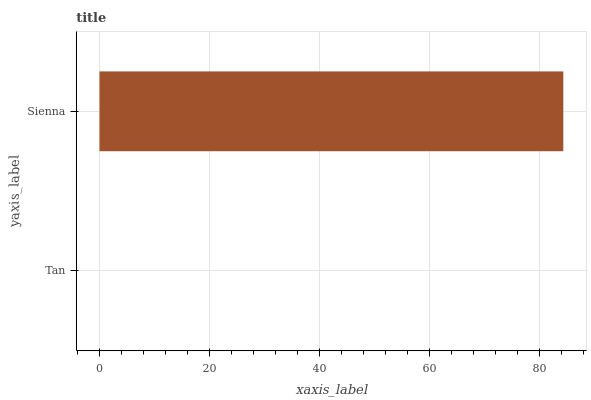Is Tan the minimum?
Answer yes or no. Yes. Is Sienna the maximum?
Answer yes or no. Yes. Is Sienna the minimum?
Answer yes or no. No. Is Sienna greater than Tan?
Answer yes or no. Yes. Is Tan less than Sienna?
Answer yes or no. Yes. Is Tan greater than Sienna?
Answer yes or no. No. Is Sienna less than Tan?
Answer yes or no. No. Is Sienna the high median?
Answer yes or no. Yes. Is Tan the low median?
Answer yes or no. Yes. Is Tan the high median?
Answer yes or no. No. Is Sienna the low median?
Answer yes or no. No. 